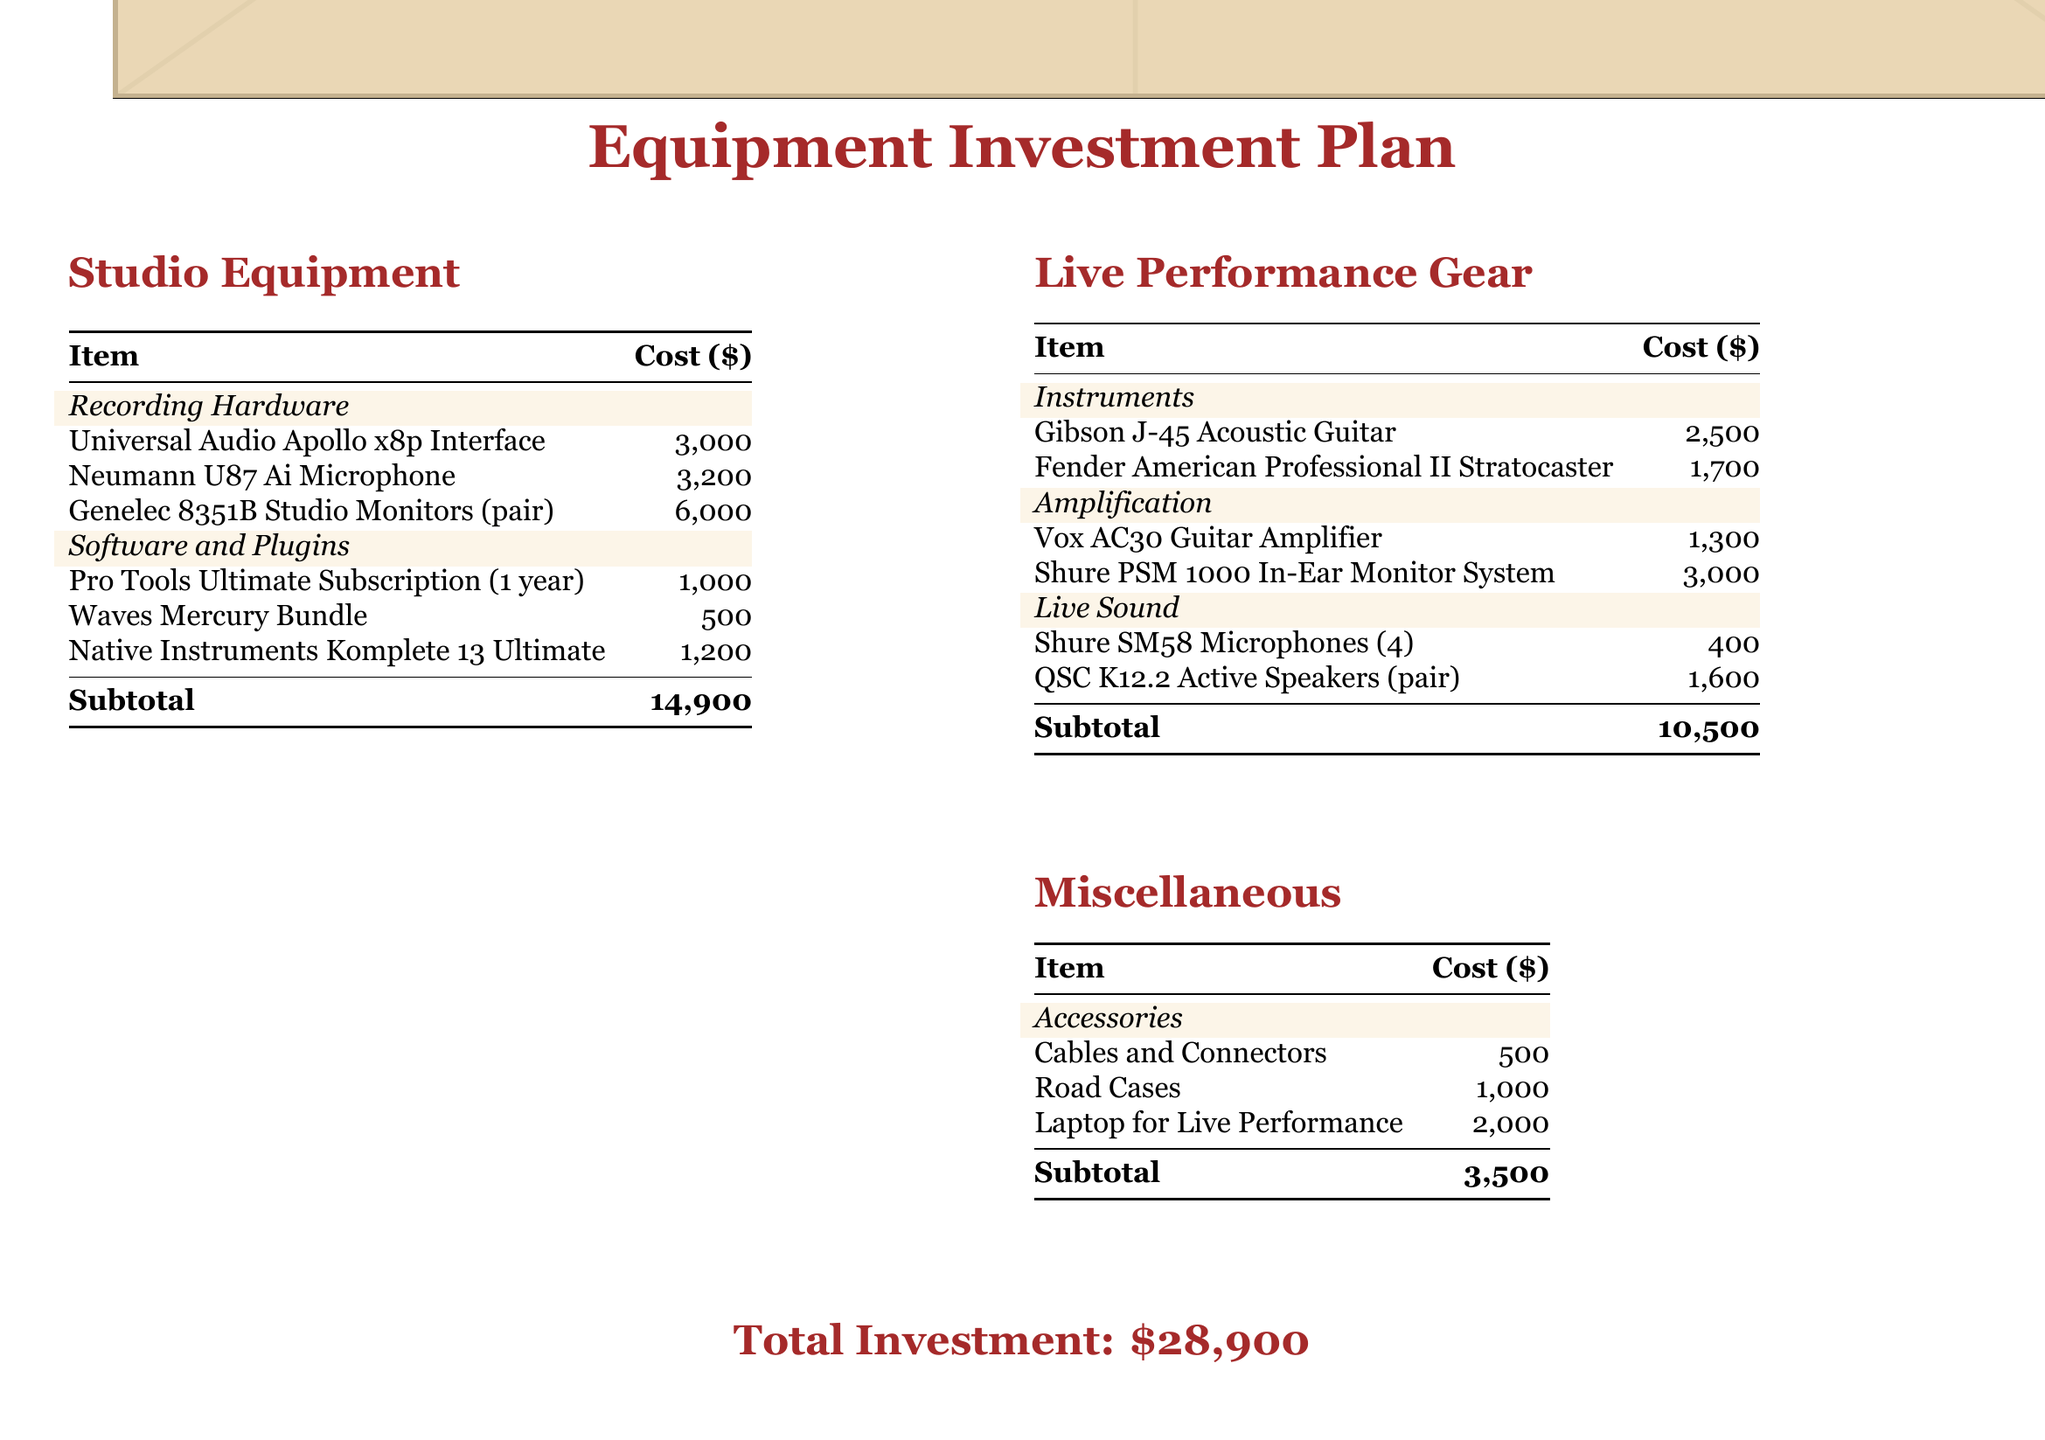What is the total investment? The total investment is clearly stated at the bottom of the document, summing up all the costs listed in the budget.
Answer: $28,900 How much does the Neumann U87 Ai Microphone cost? The cost for the Neumann U87 Ai Microphone can be found under the Recording Hardware section in the studio equipment table.
Answer: $3,200 What is included in the Live Performance Gear category? The Live Performance Gear category consists of instruments, amplification, and live sound items as detailed in the document.
Answer: Instruments, Amplification, Live Sound How much is spent on accessories? The Accessories section lists the costs associated with accessories, which are summed up at the bottom.
Answer: $3,500 Which guitar amplifier is listed in the document? The specific guitar amplifier mentioned can be found in the Amplification section of the Live Performance Gear table.
Answer: Vox AC30 Guitar Amplifier How many Shure SM58 Microphones are included in the plan? The quantity of Shure SM58 Microphones is specified in the Live Sound section of the document.
Answer: 4 What is the cost of the Gibson J-45 Acoustic Guitar? The cost for the Gibson J-45 Acoustic Guitar is provided under the Instruments section of Live Performance Gear.
Answer: $2,500 What is the subtotal for studio equipment? The subtotal for studio equipment is listed at the bottom of the Studio Equipment table.
Answer: $14,900 What type of software subscription is included in the studio upgrade? The document specifies a type of software subscription within the Software and Plugins section for studio equipment.
Answer: Pro Tools Ultimate Subscription 